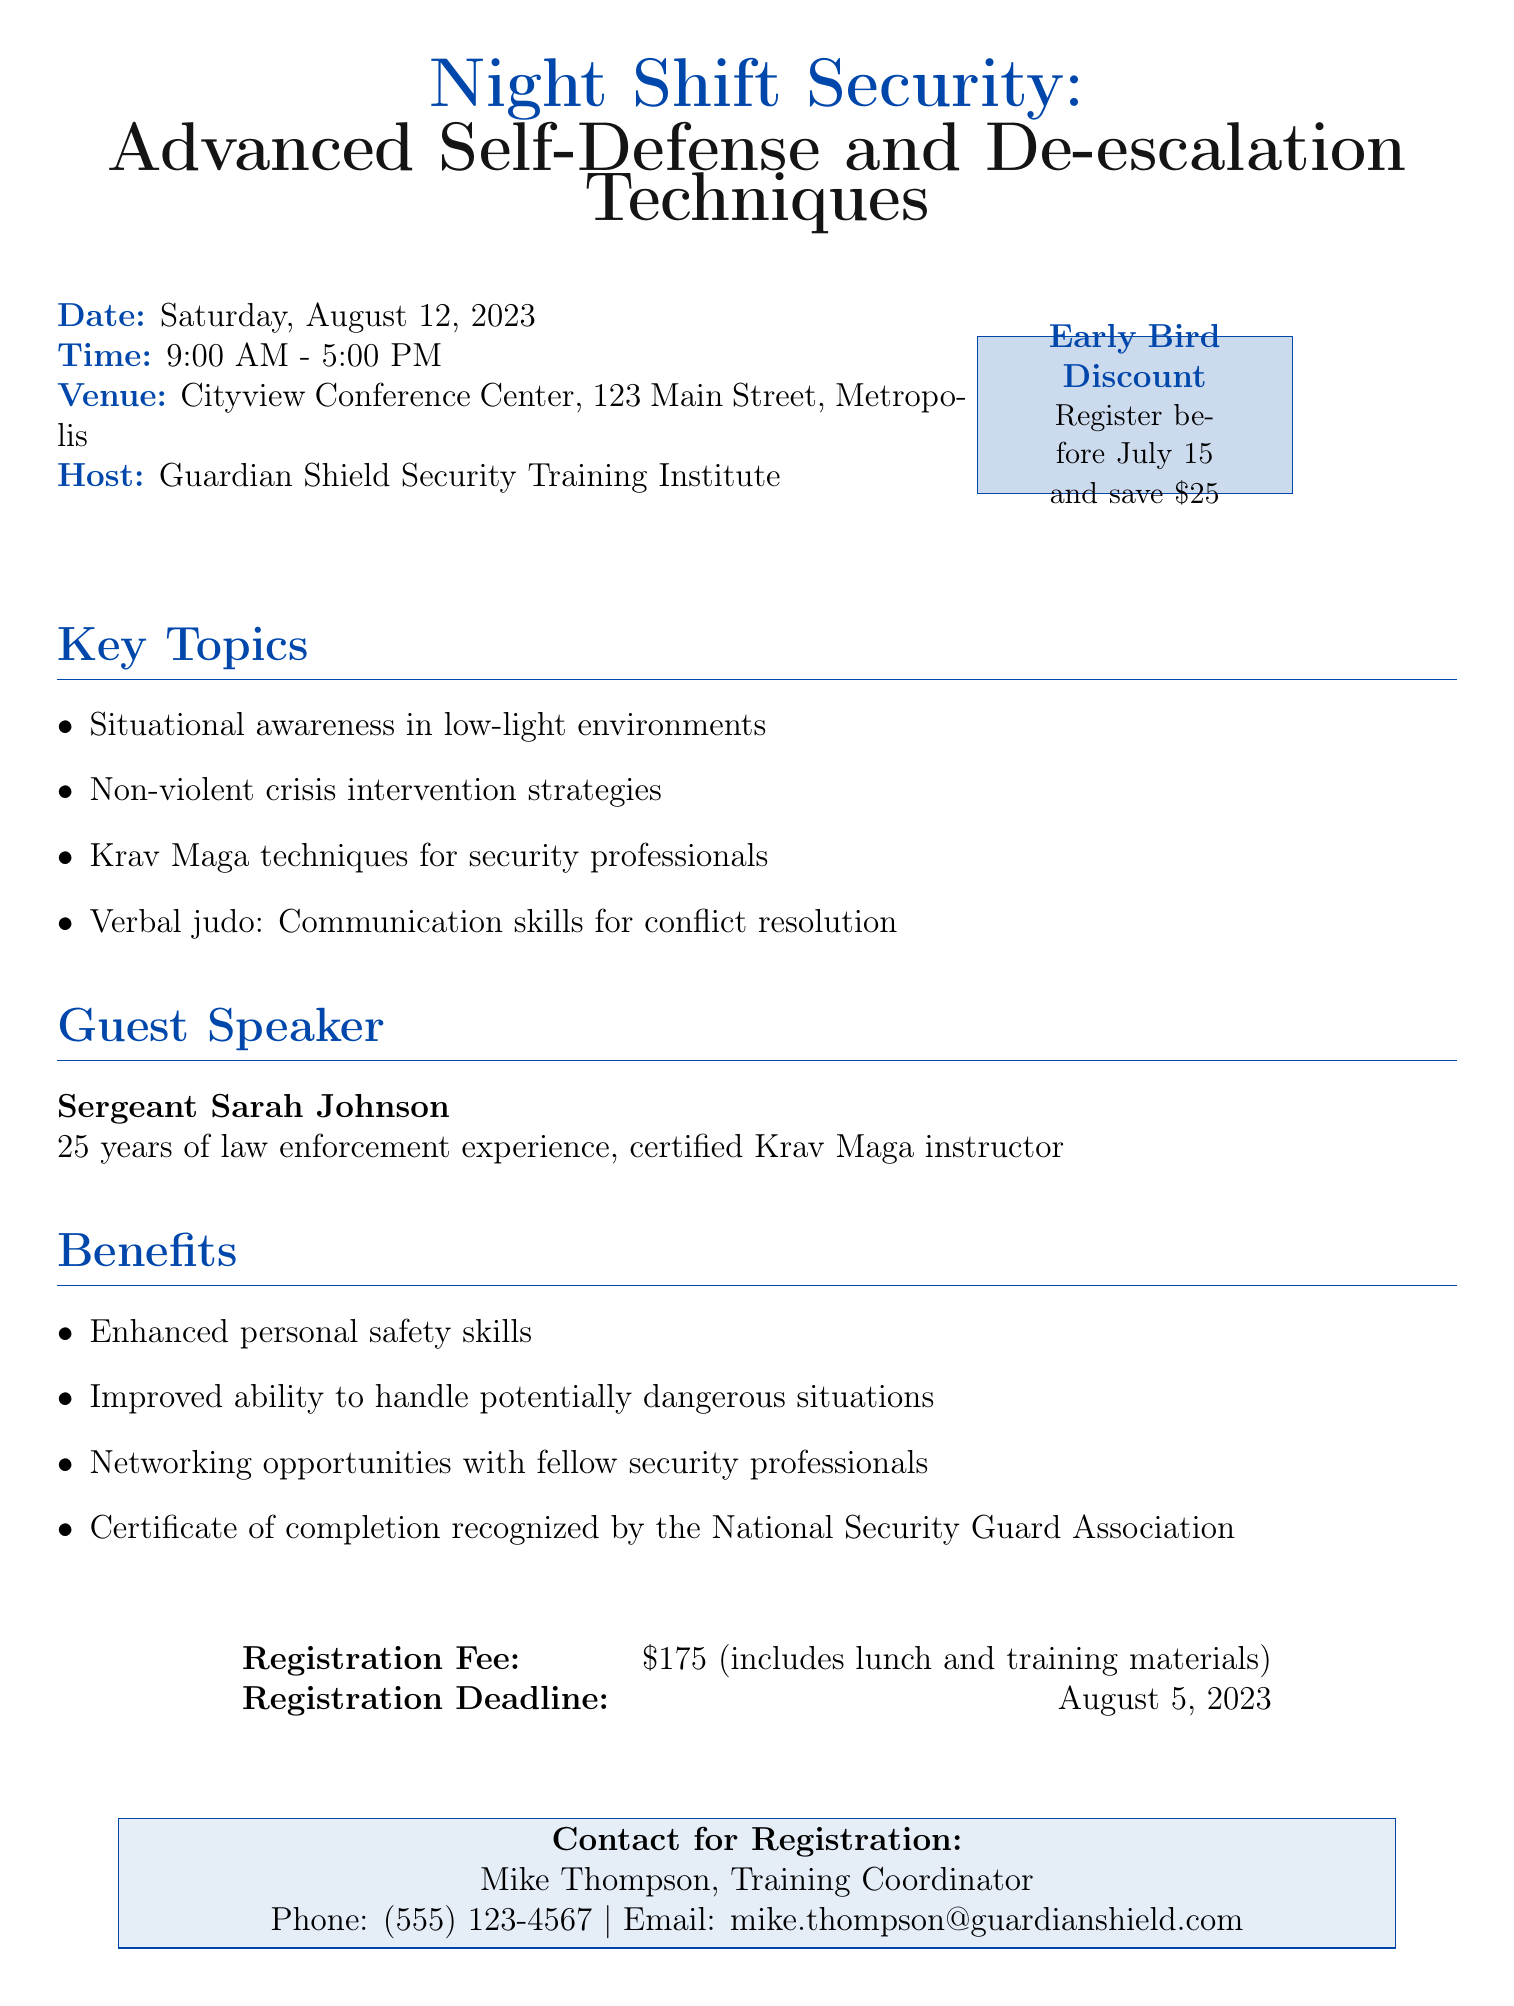What is the title of the seminar? The title of the seminar is presented at the top of the document and is "Night Shift Security: Advanced Self-Defense and De-escalation Techniques."
Answer: Night Shift Security: Advanced Self-Defense and De-escalation Techniques Who is hosting the seminar? The hosting organization is mentioned in the document and is "Guardian Shield Security Training Institute."
Answer: Guardian Shield Security Training Institute What date is the seminar scheduled for? The date of the seminar is explicitly stated in the document as "Saturday, August 12, 2023."
Answer: Saturday, August 12, 2023 What is the early bird discount amount? The amount of the early bird discount is provided in the document as "$25."
Answer: $25 Who is the guest speaker? The document lists the guest speaker as "Sergeant Sarah Johnson."
Answer: Sergeant Sarah Johnson What is the registration deadline? The registration deadline is clearly stated in the document as "August 5, 2023."
Answer: August 5, 2023 How long is the seminar? The document mentions that the seminar runs from "9:00 AM to 5:00 PM," making it an eight-hour event.
Answer: 8 hours What recognition will participants receive? The benefits section notes that participants will receive a "Certificate of completion recognized by the National Security Guard Association."
Answer: Certificate of completion recognized by the National Security Guard Association What is included in the registration fee? The document specifies that the registration fee includes "lunch and training materials."
Answer: lunch and training materials 